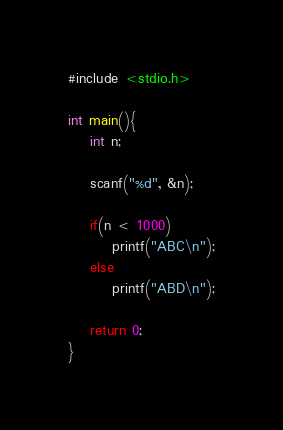Convert code to text. <code><loc_0><loc_0><loc_500><loc_500><_C_>
#include <stdio.h>

int main(){
    int n;

    scanf("%d", &n);

    if(n < 1000)
        printf("ABC\n");
    else
        printf("ABD\n");
    
    return 0;
}</code> 